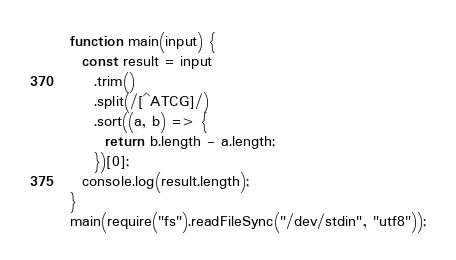<code> <loc_0><loc_0><loc_500><loc_500><_JavaScript_>function main(input) {
  const result = input
    .trim()
    .split(/[^ATCG]/)
    .sort((a, b) => {
      return b.length - a.length;
    })[0];
  console.log(result.length);
}
main(require("fs").readFileSync("/dev/stdin", "utf8"));
</code> 